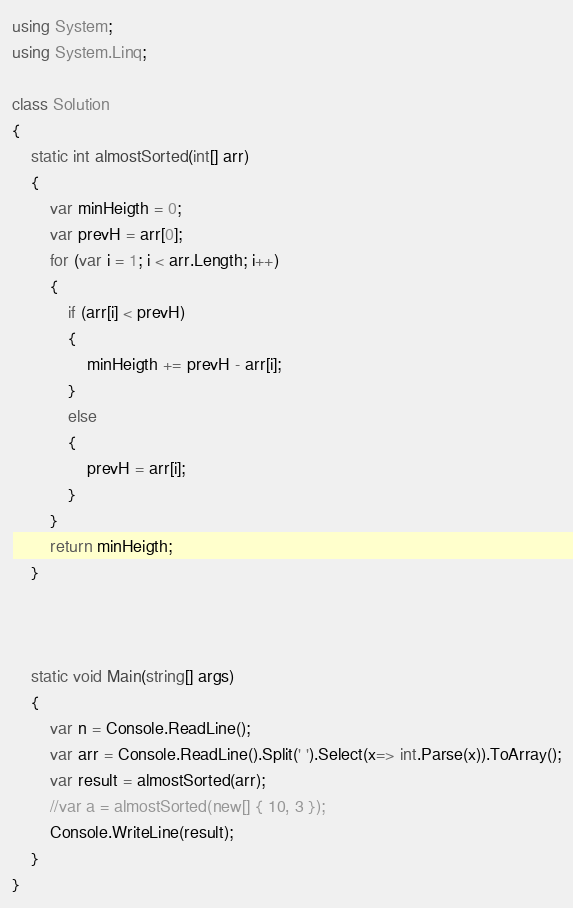<code> <loc_0><loc_0><loc_500><loc_500><_C#_>using System;
using System.Linq;

class Solution
{
    static int almostSorted(int[] arr)
    {
        var minHeigth = 0;
        var prevH = arr[0];
        for (var i = 1; i < arr.Length; i++)
        {
            if (arr[i] < prevH)
            {
                minHeigth += prevH - arr[i];
            }
            else 
            {
                prevH = arr[i];
            }
        }
        return minHeigth;
    }



    static void Main(string[] args)
    {
        var n = Console.ReadLine();
        var arr = Console.ReadLine().Split(' ').Select(x=> int.Parse(x)).ToArray();
        var result = almostSorted(arr);
        //var a = almostSorted(new[] { 10, 3 });
        Console.WriteLine(result);
    }
}</code> 